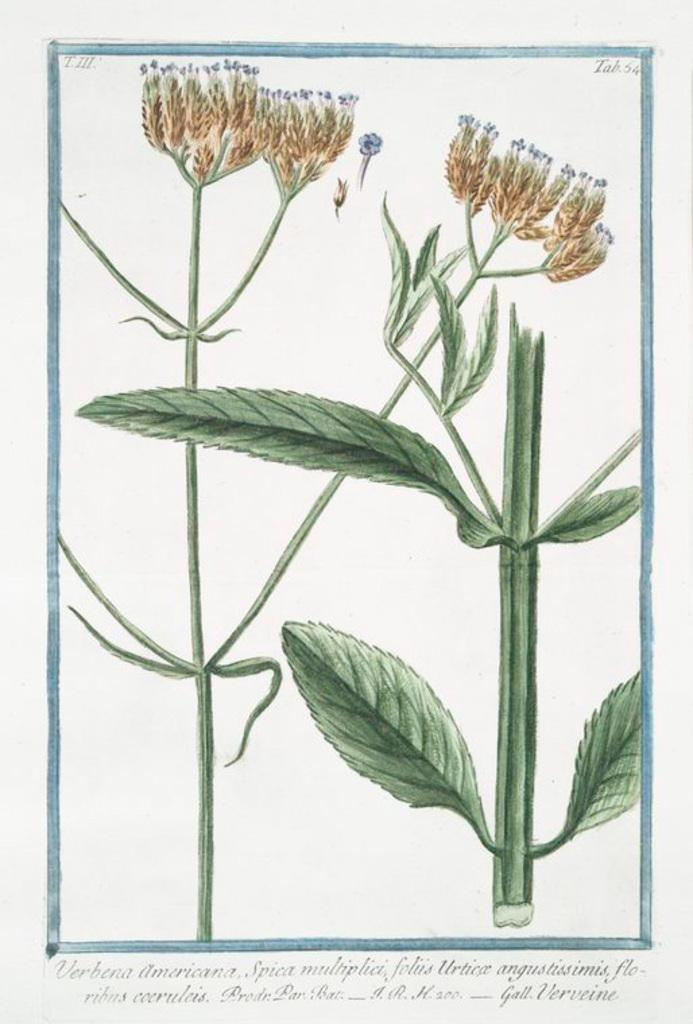What is the format of the image? The image resembles a page in a book. What can be found at the bottom of the image? There is text at the bottom of the image. What type of plant elements are present in the image? There are leaves, stems, and flower-like objects in the image. What type of flower is the governor holding in the image? There is no governor or flower present in the image; it features a page from a book with text and plant elements. 